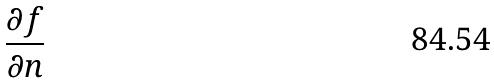Convert formula to latex. <formula><loc_0><loc_0><loc_500><loc_500>\frac { \partial f } { \partial n }</formula> 